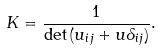Convert formula to latex. <formula><loc_0><loc_0><loc_500><loc_500>K = \frac { 1 } { \det \, ( u _ { i j } + u \delta _ { i j } ) } .</formula> 